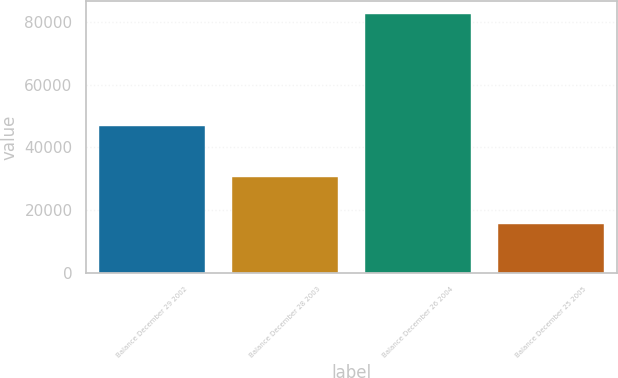Convert chart to OTSL. <chart><loc_0><loc_0><loc_500><loc_500><bar_chart><fcel>Balance December 29 2002<fcel>Balance December 28 2003<fcel>Balance December 26 2004<fcel>Balance December 25 2005<nl><fcel>46814<fcel>30484<fcel>82388<fcel>15348<nl></chart> 